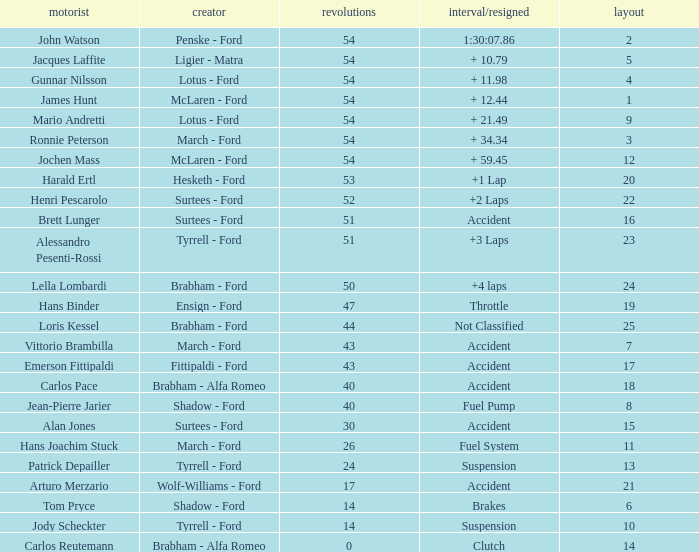How many laps did Emerson Fittipaldi do on a grid larger than 14, and when was the Time/Retired of accident? 1.0. Parse the table in full. {'header': ['motorist', 'creator', 'revolutions', 'interval/resigned', 'layout'], 'rows': [['John Watson', 'Penske - Ford', '54', '1:30:07.86', '2'], ['Jacques Laffite', 'Ligier - Matra', '54', '+ 10.79', '5'], ['Gunnar Nilsson', 'Lotus - Ford', '54', '+ 11.98', '4'], ['James Hunt', 'McLaren - Ford', '54', '+ 12.44', '1'], ['Mario Andretti', 'Lotus - Ford', '54', '+ 21.49', '9'], ['Ronnie Peterson', 'March - Ford', '54', '+ 34.34', '3'], ['Jochen Mass', 'McLaren - Ford', '54', '+ 59.45', '12'], ['Harald Ertl', 'Hesketh - Ford', '53', '+1 Lap', '20'], ['Henri Pescarolo', 'Surtees - Ford', '52', '+2 Laps', '22'], ['Brett Lunger', 'Surtees - Ford', '51', 'Accident', '16'], ['Alessandro Pesenti-Rossi', 'Tyrrell - Ford', '51', '+3 Laps', '23'], ['Lella Lombardi', 'Brabham - Ford', '50', '+4 laps', '24'], ['Hans Binder', 'Ensign - Ford', '47', 'Throttle', '19'], ['Loris Kessel', 'Brabham - Ford', '44', 'Not Classified', '25'], ['Vittorio Brambilla', 'March - Ford', '43', 'Accident', '7'], ['Emerson Fittipaldi', 'Fittipaldi - Ford', '43', 'Accident', '17'], ['Carlos Pace', 'Brabham - Alfa Romeo', '40', 'Accident', '18'], ['Jean-Pierre Jarier', 'Shadow - Ford', '40', 'Fuel Pump', '8'], ['Alan Jones', 'Surtees - Ford', '30', 'Accident', '15'], ['Hans Joachim Stuck', 'March - Ford', '26', 'Fuel System', '11'], ['Patrick Depailler', 'Tyrrell - Ford', '24', 'Suspension', '13'], ['Arturo Merzario', 'Wolf-Williams - Ford', '17', 'Accident', '21'], ['Tom Pryce', 'Shadow - Ford', '14', 'Brakes', '6'], ['Jody Scheckter', 'Tyrrell - Ford', '14', 'Suspension', '10'], ['Carlos Reutemann', 'Brabham - Alfa Romeo', '0', 'Clutch', '14']]} 